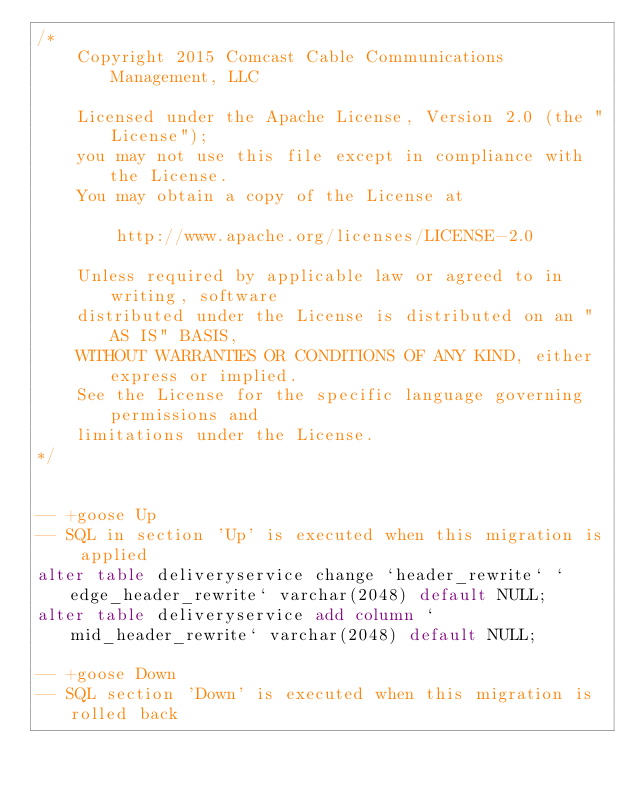<code> <loc_0><loc_0><loc_500><loc_500><_SQL_>/*
	Copyright 2015 Comcast Cable Communications Management, LLC
	
	Licensed under the Apache License, Version 2.0 (the "License");
	you may not use this file except in compliance with the License.
	You may obtain a copy of the License at
	
	    http://www.apache.org/licenses/LICENSE-2.0
	
	Unless required by applicable law or agreed to in writing, software
	distributed under the License is distributed on an "AS IS" BASIS,
	WITHOUT WARRANTIES OR CONDITIONS OF ANY KIND, either express or implied.
	See the License for the specific language governing permissions and
	limitations under the License.
*/


-- +goose Up
-- SQL in section 'Up' is executed when this migration is applied
alter table deliveryservice change `header_rewrite` `edge_header_rewrite` varchar(2048) default NULL;
alter table deliveryservice add column `mid_header_rewrite` varchar(2048) default NULL;

-- +goose Down
-- SQL section 'Down' is executed when this migration is rolled back

</code> 